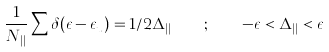<formula> <loc_0><loc_0><loc_500><loc_500>\frac { 1 } { N _ { | | } } \sum \delta ( \epsilon - \epsilon _ { u } ) = 1 / 2 \Delta _ { | | } \quad ; \quad - \epsilon < \Delta _ { | | } < \epsilon</formula> 